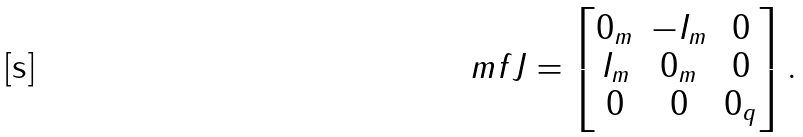<formula> <loc_0><loc_0><loc_500><loc_500>\ m f { J } = \begin{bmatrix} 0 _ { m } & - I _ { m } & 0 \\ I _ { m } & 0 _ { m } & 0 \\ 0 & 0 & 0 _ { q } \end{bmatrix} .</formula> 